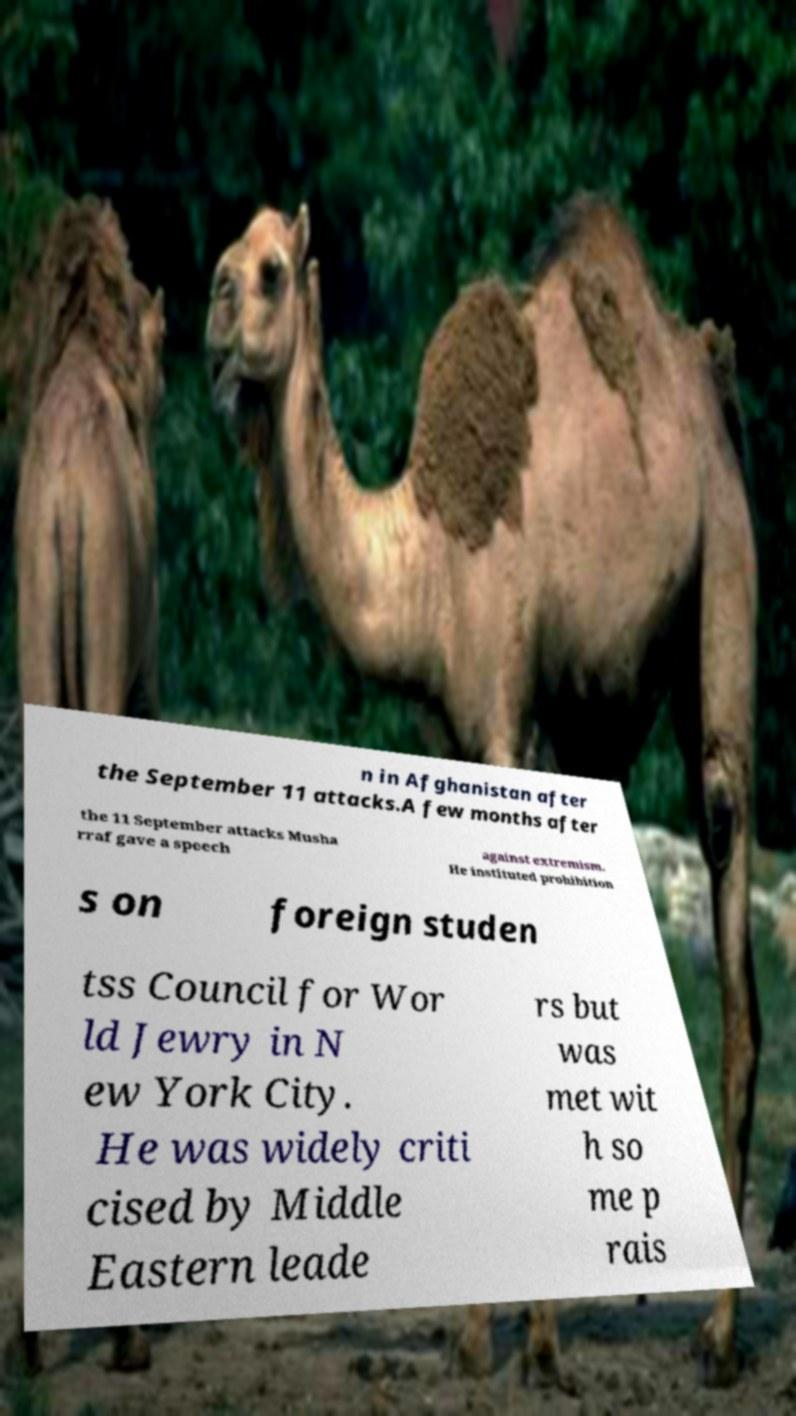Can you read and provide the text displayed in the image?This photo seems to have some interesting text. Can you extract and type it out for me? n in Afghanistan after the September 11 attacks.A few months after the 11 September attacks Musha rraf gave a speech against extremism. He instituted prohibition s on foreign studen tss Council for Wor ld Jewry in N ew York City. He was widely criti cised by Middle Eastern leade rs but was met wit h so me p rais 